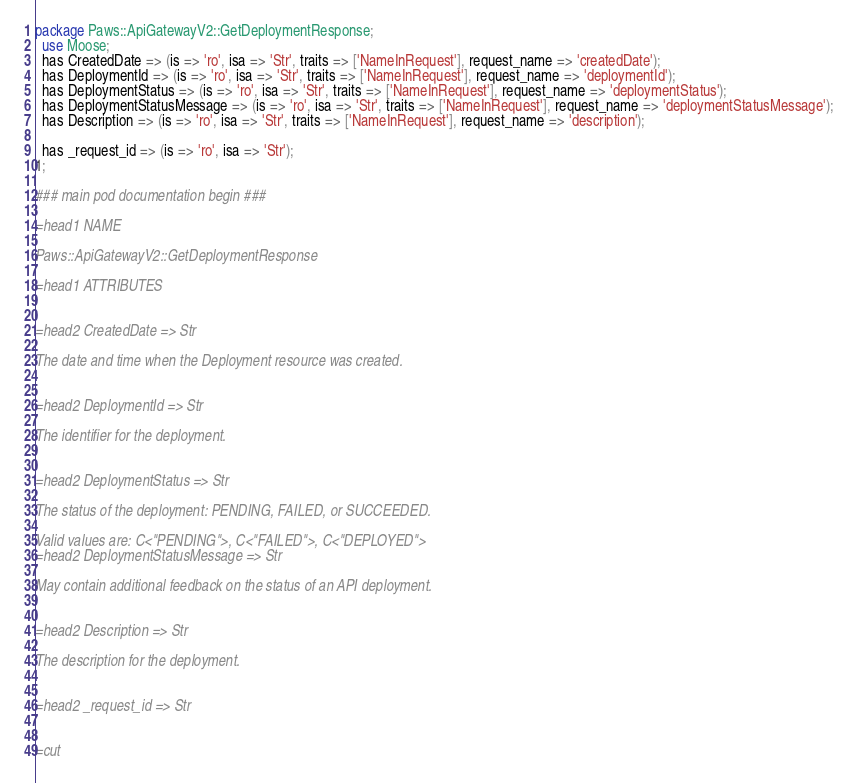Convert code to text. <code><loc_0><loc_0><loc_500><loc_500><_Perl_>
package Paws::ApiGatewayV2::GetDeploymentResponse;
  use Moose;
  has CreatedDate => (is => 'ro', isa => 'Str', traits => ['NameInRequest'], request_name => 'createdDate');
  has DeploymentId => (is => 'ro', isa => 'Str', traits => ['NameInRequest'], request_name => 'deploymentId');
  has DeploymentStatus => (is => 'ro', isa => 'Str', traits => ['NameInRequest'], request_name => 'deploymentStatus');
  has DeploymentStatusMessage => (is => 'ro', isa => 'Str', traits => ['NameInRequest'], request_name => 'deploymentStatusMessage');
  has Description => (is => 'ro', isa => 'Str', traits => ['NameInRequest'], request_name => 'description');

  has _request_id => (is => 'ro', isa => 'Str');
1;

### main pod documentation begin ###

=head1 NAME

Paws::ApiGatewayV2::GetDeploymentResponse

=head1 ATTRIBUTES


=head2 CreatedDate => Str

The date and time when the Deployment resource was created.


=head2 DeploymentId => Str

The identifier for the deployment.


=head2 DeploymentStatus => Str

The status of the deployment: PENDING, FAILED, or SUCCEEDED.

Valid values are: C<"PENDING">, C<"FAILED">, C<"DEPLOYED">
=head2 DeploymentStatusMessage => Str

May contain additional feedback on the status of an API deployment.


=head2 Description => Str

The description for the deployment.


=head2 _request_id => Str


=cut

</code> 